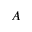<formula> <loc_0><loc_0><loc_500><loc_500>A</formula> 